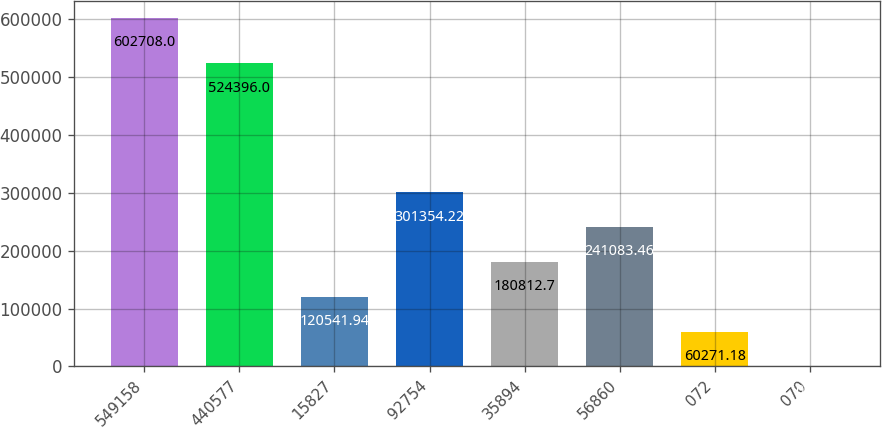Convert chart to OTSL. <chart><loc_0><loc_0><loc_500><loc_500><bar_chart><fcel>549158<fcel>440577<fcel>15827<fcel>92754<fcel>35894<fcel>56860<fcel>072<fcel>070<nl><fcel>602708<fcel>524396<fcel>120542<fcel>301354<fcel>180813<fcel>241083<fcel>60271.2<fcel>0.42<nl></chart> 